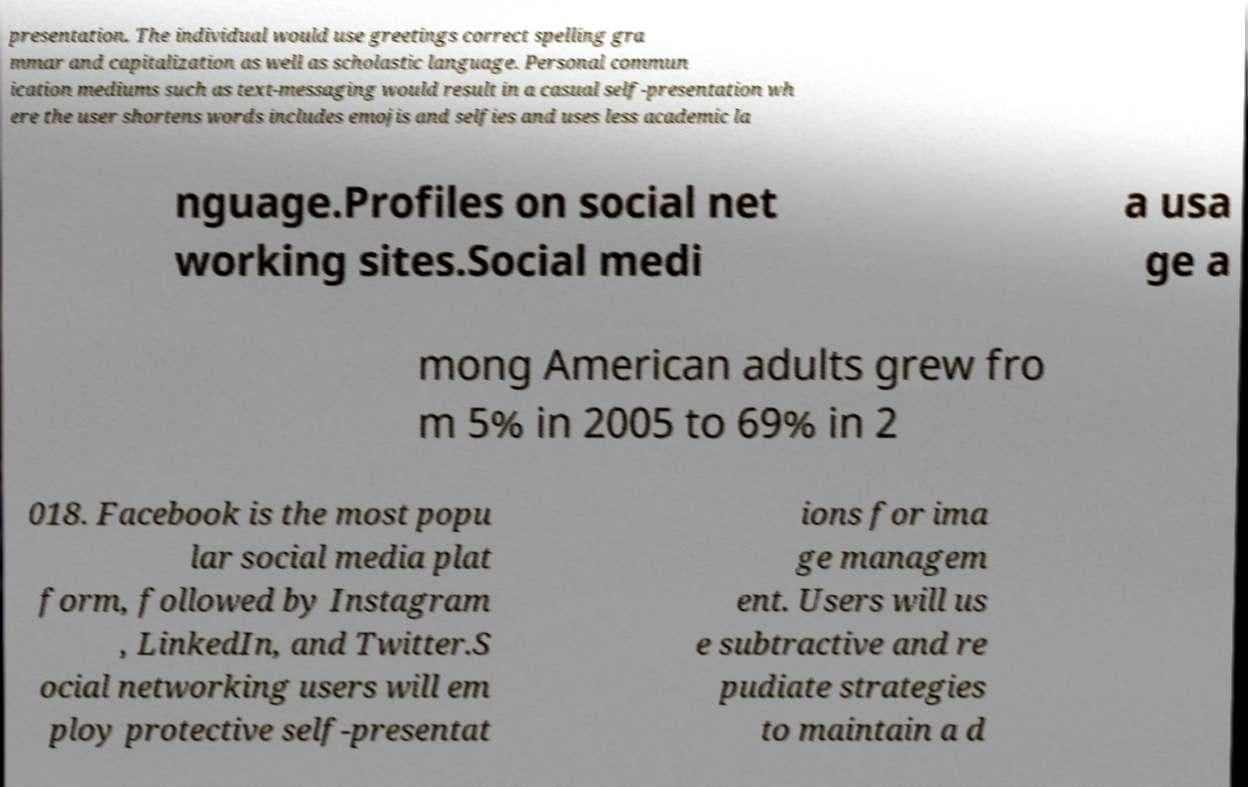There's text embedded in this image that I need extracted. Can you transcribe it verbatim? presentation. The individual would use greetings correct spelling gra mmar and capitalization as well as scholastic language. Personal commun ication mediums such as text-messaging would result in a casual self-presentation wh ere the user shortens words includes emojis and selfies and uses less academic la nguage.Profiles on social net working sites.Social medi a usa ge a mong American adults grew fro m 5% in 2005 to 69% in 2 018. Facebook is the most popu lar social media plat form, followed by Instagram , LinkedIn, and Twitter.S ocial networking users will em ploy protective self-presentat ions for ima ge managem ent. Users will us e subtractive and re pudiate strategies to maintain a d 